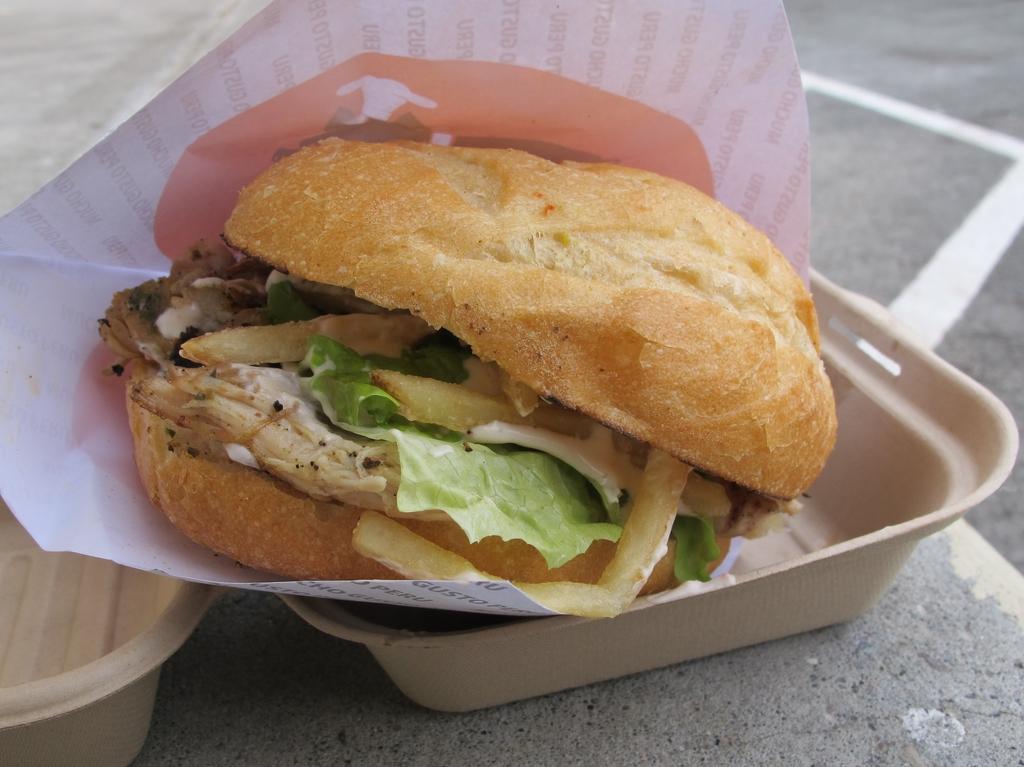Can you describe this image briefly? In the image we can see some plates and food and paper. 